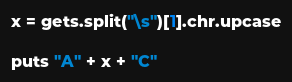<code> <loc_0><loc_0><loc_500><loc_500><_Ruby_>x = gets.split("\s")[1].chr.upcase

puts "A" + x + "C"</code> 